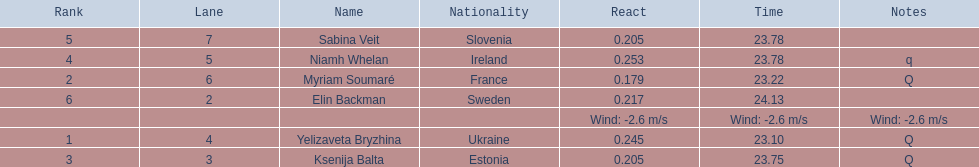Are any of the lanes in consecutive order? No. 